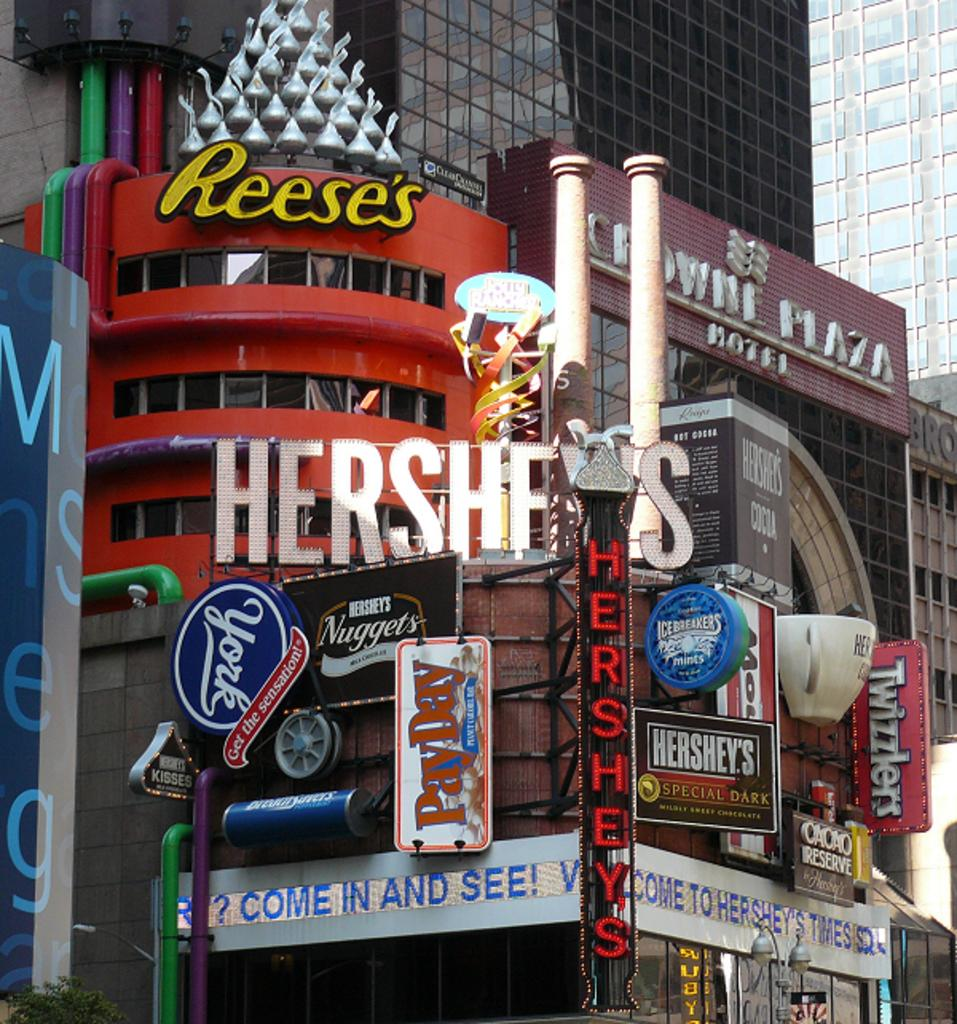What type of structures can be seen in the image? There are buildings in the image. What feature do the buildings have? The buildings have glass doors. How can the buildings be identified in the image? There are name boards attached to the buildings. What type of snails can be seen crawling on the name boards in the image? There are no snails present in the image; it only features buildings with glass doors and name boards. 